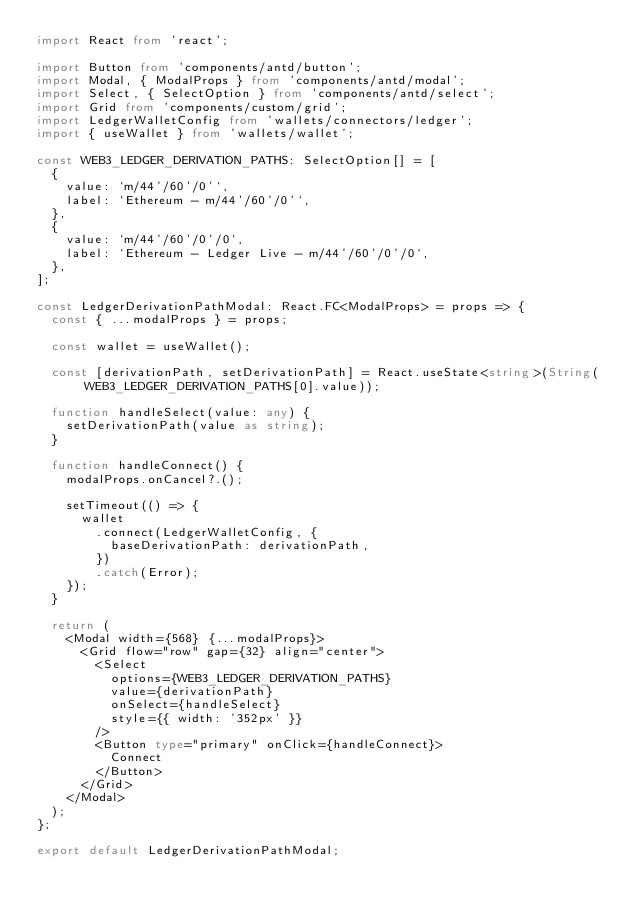Convert code to text. <code><loc_0><loc_0><loc_500><loc_500><_TypeScript_>import React from 'react';

import Button from 'components/antd/button';
import Modal, { ModalProps } from 'components/antd/modal';
import Select, { SelectOption } from 'components/antd/select';
import Grid from 'components/custom/grid';
import LedgerWalletConfig from 'wallets/connectors/ledger';
import { useWallet } from 'wallets/wallet';

const WEB3_LEDGER_DERIVATION_PATHS: SelectOption[] = [
  {
    value: `m/44'/60'/0'`,
    label: `Ethereum - m/44'/60'/0'`,
  },
  {
    value: `m/44'/60'/0'/0`,
    label: `Ethereum - Ledger Live - m/44'/60'/0'/0`,
  },
];

const LedgerDerivationPathModal: React.FC<ModalProps> = props => {
  const { ...modalProps } = props;

  const wallet = useWallet();

  const [derivationPath, setDerivationPath] = React.useState<string>(String(WEB3_LEDGER_DERIVATION_PATHS[0].value));

  function handleSelect(value: any) {
    setDerivationPath(value as string);
  }

  function handleConnect() {
    modalProps.onCancel?.();

    setTimeout(() => {
      wallet
        .connect(LedgerWalletConfig, {
          baseDerivationPath: derivationPath,
        })
        .catch(Error);
    });
  }

  return (
    <Modal width={568} {...modalProps}>
      <Grid flow="row" gap={32} align="center">
        <Select
          options={WEB3_LEDGER_DERIVATION_PATHS}
          value={derivationPath}
          onSelect={handleSelect}
          style={{ width: '352px' }}
        />
        <Button type="primary" onClick={handleConnect}>
          Connect
        </Button>
      </Grid>
    </Modal>
  );
};

export default LedgerDerivationPathModal;
</code> 